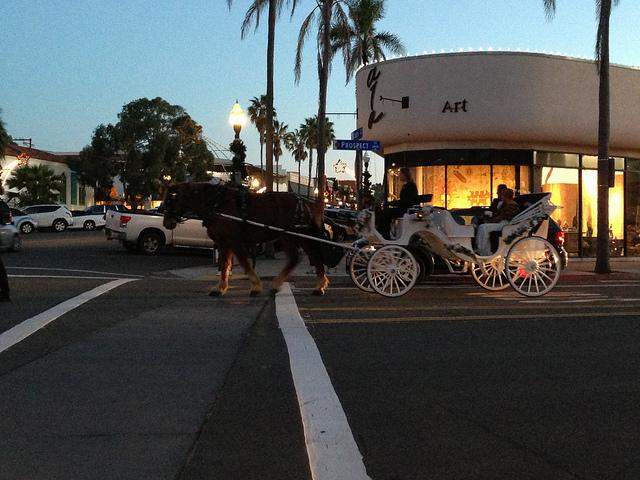What 3 letters are on the building?
Be succinct. Art. What kind of animal do you see?
Keep it brief. Horse. What color is the horse carriage?
Give a very brief answer. White. 